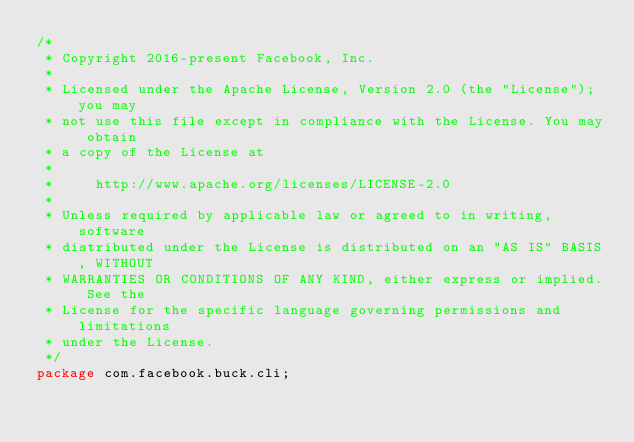<code> <loc_0><loc_0><loc_500><loc_500><_Java_>/*
 * Copyright 2016-present Facebook, Inc.
 *
 * Licensed under the Apache License, Version 2.0 (the "License"); you may
 * not use this file except in compliance with the License. You may obtain
 * a copy of the License at
 *
 *     http://www.apache.org/licenses/LICENSE-2.0
 *
 * Unless required by applicable law or agreed to in writing, software
 * distributed under the License is distributed on an "AS IS" BASIS, WITHOUT
 * WARRANTIES OR CONDITIONS OF ANY KIND, either express or implied. See the
 * License for the specific language governing permissions and limitations
 * under the License.
 */
package com.facebook.buck.cli;
</code> 